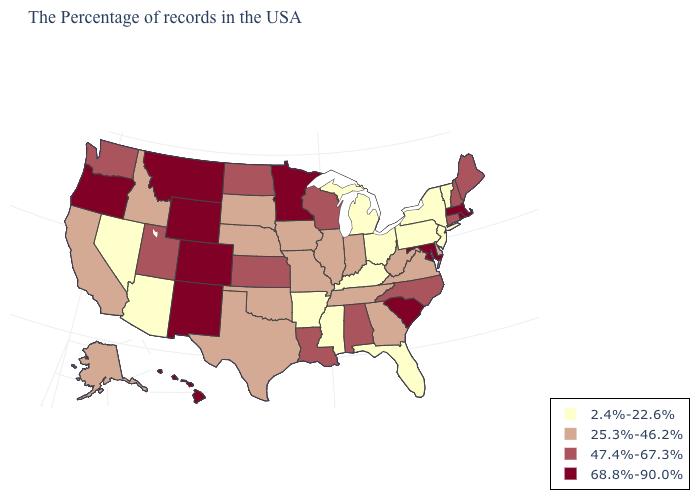What is the value of New Jersey?
Give a very brief answer. 2.4%-22.6%. How many symbols are there in the legend?
Short answer required. 4. What is the value of North Carolina?
Be succinct. 47.4%-67.3%. What is the lowest value in the South?
Short answer required. 2.4%-22.6%. Name the states that have a value in the range 25.3%-46.2%?
Keep it brief. Delaware, Virginia, West Virginia, Georgia, Indiana, Tennessee, Illinois, Missouri, Iowa, Nebraska, Oklahoma, Texas, South Dakota, Idaho, California, Alaska. Does the first symbol in the legend represent the smallest category?
Give a very brief answer. Yes. What is the value of Vermont?
Write a very short answer. 2.4%-22.6%. What is the lowest value in the USA?
Keep it brief. 2.4%-22.6%. What is the value of Alaska?
Quick response, please. 25.3%-46.2%. Among the states that border North Carolina , does South Carolina have the highest value?
Answer briefly. Yes. What is the value of Idaho?
Quick response, please. 25.3%-46.2%. Which states hav the highest value in the South?
Write a very short answer. Maryland, South Carolina. Which states have the highest value in the USA?
Give a very brief answer. Massachusetts, Rhode Island, Maryland, South Carolina, Minnesota, Wyoming, Colorado, New Mexico, Montana, Oregon, Hawaii. Among the states that border New York , which have the highest value?
Be succinct. Massachusetts. What is the value of Florida?
Be succinct. 2.4%-22.6%. 